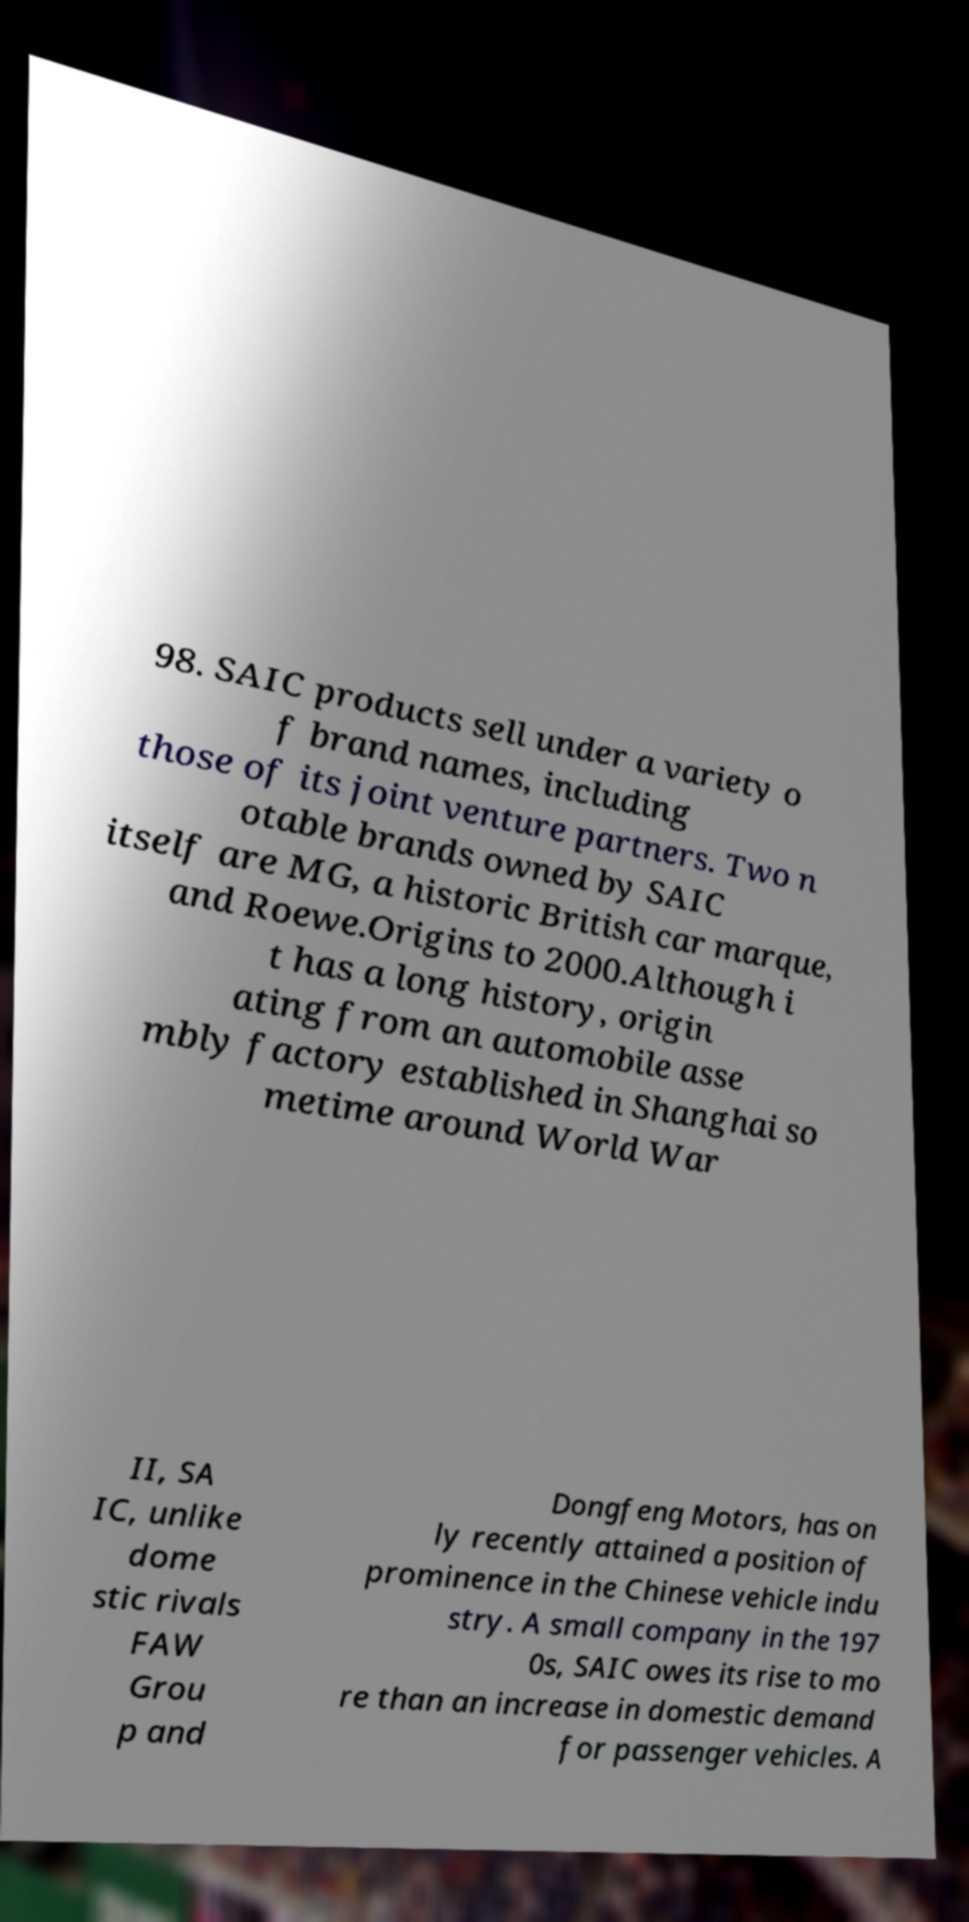What messages or text are displayed in this image? I need them in a readable, typed format. 98. SAIC products sell under a variety o f brand names, including those of its joint venture partners. Two n otable brands owned by SAIC itself are MG, a historic British car marque, and Roewe.Origins to 2000.Although i t has a long history, origin ating from an automobile asse mbly factory established in Shanghai so metime around World War II, SA IC, unlike dome stic rivals FAW Grou p and Dongfeng Motors, has on ly recently attained a position of prominence in the Chinese vehicle indu stry. A small company in the 197 0s, SAIC owes its rise to mo re than an increase in domestic demand for passenger vehicles. A 